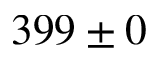<formula> <loc_0><loc_0><loc_500><loc_500>3 9 9 \pm 0</formula> 